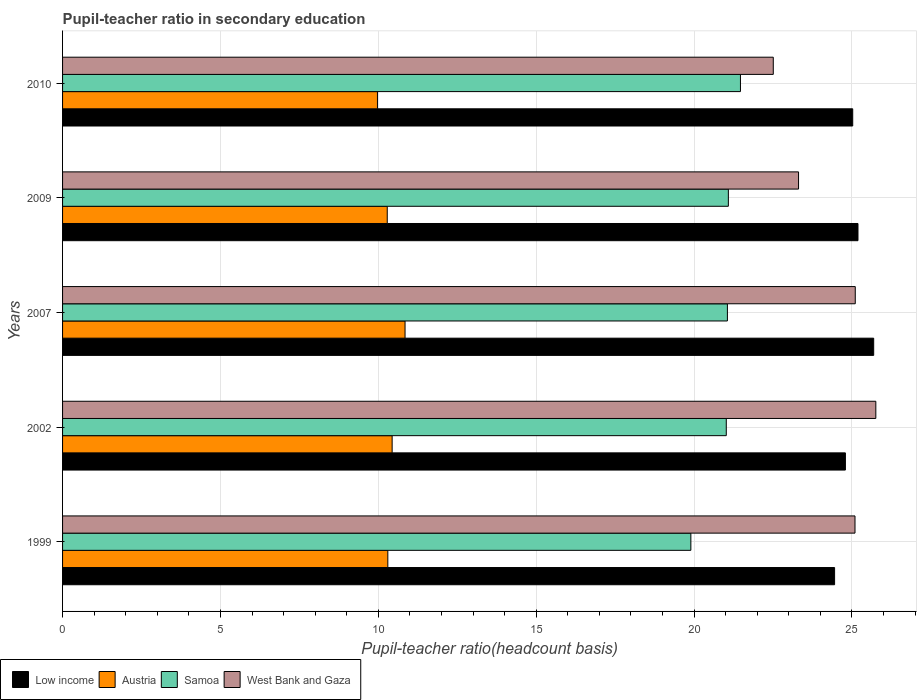How many different coloured bars are there?
Your answer should be compact. 4. How many groups of bars are there?
Ensure brevity in your answer.  5. Are the number of bars on each tick of the Y-axis equal?
Provide a short and direct response. Yes. What is the label of the 3rd group of bars from the top?
Ensure brevity in your answer.  2007. In how many cases, is the number of bars for a given year not equal to the number of legend labels?
Provide a short and direct response. 0. What is the pupil-teacher ratio in secondary education in Samoa in 2009?
Offer a very short reply. 21.09. Across all years, what is the maximum pupil-teacher ratio in secondary education in Austria?
Ensure brevity in your answer.  10.85. Across all years, what is the minimum pupil-teacher ratio in secondary education in Samoa?
Your answer should be very brief. 19.9. What is the total pupil-teacher ratio in secondary education in Samoa in the graph?
Offer a very short reply. 104.53. What is the difference between the pupil-teacher ratio in secondary education in Low income in 1999 and that in 2010?
Your answer should be very brief. -0.57. What is the difference between the pupil-teacher ratio in secondary education in West Bank and Gaza in 2009 and the pupil-teacher ratio in secondary education in Low income in 2002?
Make the answer very short. -1.48. What is the average pupil-teacher ratio in secondary education in Samoa per year?
Provide a short and direct response. 20.91. In the year 2002, what is the difference between the pupil-teacher ratio in secondary education in Samoa and pupil-teacher ratio in secondary education in Austria?
Make the answer very short. 10.58. In how many years, is the pupil-teacher ratio in secondary education in West Bank and Gaza greater than 5 ?
Give a very brief answer. 5. What is the ratio of the pupil-teacher ratio in secondary education in Samoa in 2002 to that in 2007?
Provide a short and direct response. 1. Is the difference between the pupil-teacher ratio in secondary education in Samoa in 1999 and 2002 greater than the difference between the pupil-teacher ratio in secondary education in Austria in 1999 and 2002?
Give a very brief answer. No. What is the difference between the highest and the second highest pupil-teacher ratio in secondary education in Austria?
Provide a succinct answer. 0.41. What is the difference between the highest and the lowest pupil-teacher ratio in secondary education in Austria?
Offer a very short reply. 0.87. Is the sum of the pupil-teacher ratio in secondary education in Austria in 2002 and 2009 greater than the maximum pupil-teacher ratio in secondary education in Samoa across all years?
Provide a succinct answer. No. Is it the case that in every year, the sum of the pupil-teacher ratio in secondary education in Austria and pupil-teacher ratio in secondary education in Low income is greater than the sum of pupil-teacher ratio in secondary education in West Bank and Gaza and pupil-teacher ratio in secondary education in Samoa?
Give a very brief answer. Yes. What does the 3rd bar from the top in 2007 represents?
Your response must be concise. Austria. What does the 1st bar from the bottom in 2010 represents?
Make the answer very short. Low income. How many bars are there?
Provide a short and direct response. 20. Are all the bars in the graph horizontal?
Give a very brief answer. Yes. How many years are there in the graph?
Ensure brevity in your answer.  5. What is the difference between two consecutive major ticks on the X-axis?
Provide a short and direct response. 5. Are the values on the major ticks of X-axis written in scientific E-notation?
Keep it short and to the point. No. Does the graph contain grids?
Give a very brief answer. Yes. Where does the legend appear in the graph?
Keep it short and to the point. Bottom left. How many legend labels are there?
Offer a terse response. 4. What is the title of the graph?
Your answer should be compact. Pupil-teacher ratio in secondary education. Does "Algeria" appear as one of the legend labels in the graph?
Offer a very short reply. No. What is the label or title of the X-axis?
Ensure brevity in your answer.  Pupil-teacher ratio(headcount basis). What is the Pupil-teacher ratio(headcount basis) in Low income in 1999?
Offer a very short reply. 24.45. What is the Pupil-teacher ratio(headcount basis) in Austria in 1999?
Ensure brevity in your answer.  10.3. What is the Pupil-teacher ratio(headcount basis) in Samoa in 1999?
Your answer should be compact. 19.9. What is the Pupil-teacher ratio(headcount basis) of West Bank and Gaza in 1999?
Provide a succinct answer. 25.1. What is the Pupil-teacher ratio(headcount basis) in Low income in 2002?
Your answer should be very brief. 24.79. What is the Pupil-teacher ratio(headcount basis) of Austria in 2002?
Your answer should be very brief. 10.44. What is the Pupil-teacher ratio(headcount basis) of Samoa in 2002?
Keep it short and to the point. 21.02. What is the Pupil-teacher ratio(headcount basis) in West Bank and Gaza in 2002?
Keep it short and to the point. 25.76. What is the Pupil-teacher ratio(headcount basis) in Low income in 2007?
Offer a very short reply. 25.69. What is the Pupil-teacher ratio(headcount basis) in Austria in 2007?
Your answer should be compact. 10.85. What is the Pupil-teacher ratio(headcount basis) in Samoa in 2007?
Your answer should be compact. 21.05. What is the Pupil-teacher ratio(headcount basis) of West Bank and Gaza in 2007?
Ensure brevity in your answer.  25.1. What is the Pupil-teacher ratio(headcount basis) in Low income in 2009?
Your answer should be very brief. 25.19. What is the Pupil-teacher ratio(headcount basis) of Austria in 2009?
Your answer should be compact. 10.28. What is the Pupil-teacher ratio(headcount basis) in Samoa in 2009?
Make the answer very short. 21.09. What is the Pupil-teacher ratio(headcount basis) in West Bank and Gaza in 2009?
Your response must be concise. 23.31. What is the Pupil-teacher ratio(headcount basis) of Low income in 2010?
Make the answer very short. 25.02. What is the Pupil-teacher ratio(headcount basis) of Austria in 2010?
Your answer should be very brief. 9.97. What is the Pupil-teacher ratio(headcount basis) in Samoa in 2010?
Make the answer very short. 21.47. What is the Pupil-teacher ratio(headcount basis) in West Bank and Gaza in 2010?
Ensure brevity in your answer.  22.51. Across all years, what is the maximum Pupil-teacher ratio(headcount basis) in Low income?
Keep it short and to the point. 25.69. Across all years, what is the maximum Pupil-teacher ratio(headcount basis) of Austria?
Your answer should be compact. 10.85. Across all years, what is the maximum Pupil-teacher ratio(headcount basis) in Samoa?
Your answer should be compact. 21.47. Across all years, what is the maximum Pupil-teacher ratio(headcount basis) of West Bank and Gaza?
Make the answer very short. 25.76. Across all years, what is the minimum Pupil-teacher ratio(headcount basis) of Low income?
Your answer should be compact. 24.45. Across all years, what is the minimum Pupil-teacher ratio(headcount basis) in Austria?
Provide a succinct answer. 9.97. Across all years, what is the minimum Pupil-teacher ratio(headcount basis) of Samoa?
Your answer should be compact. 19.9. Across all years, what is the minimum Pupil-teacher ratio(headcount basis) in West Bank and Gaza?
Your response must be concise. 22.51. What is the total Pupil-teacher ratio(headcount basis) in Low income in the graph?
Your response must be concise. 125.14. What is the total Pupil-teacher ratio(headcount basis) in Austria in the graph?
Provide a succinct answer. 51.84. What is the total Pupil-teacher ratio(headcount basis) in Samoa in the graph?
Keep it short and to the point. 104.53. What is the total Pupil-teacher ratio(headcount basis) in West Bank and Gaza in the graph?
Ensure brevity in your answer.  121.77. What is the difference between the Pupil-teacher ratio(headcount basis) of Low income in 1999 and that in 2002?
Your answer should be very brief. -0.34. What is the difference between the Pupil-teacher ratio(headcount basis) in Austria in 1999 and that in 2002?
Offer a very short reply. -0.14. What is the difference between the Pupil-teacher ratio(headcount basis) in Samoa in 1999 and that in 2002?
Make the answer very short. -1.12. What is the difference between the Pupil-teacher ratio(headcount basis) of West Bank and Gaza in 1999 and that in 2002?
Give a very brief answer. -0.66. What is the difference between the Pupil-teacher ratio(headcount basis) in Low income in 1999 and that in 2007?
Offer a very short reply. -1.24. What is the difference between the Pupil-teacher ratio(headcount basis) in Austria in 1999 and that in 2007?
Provide a succinct answer. -0.55. What is the difference between the Pupil-teacher ratio(headcount basis) in Samoa in 1999 and that in 2007?
Ensure brevity in your answer.  -1.16. What is the difference between the Pupil-teacher ratio(headcount basis) in West Bank and Gaza in 1999 and that in 2007?
Your answer should be very brief. -0.01. What is the difference between the Pupil-teacher ratio(headcount basis) of Low income in 1999 and that in 2009?
Give a very brief answer. -0.74. What is the difference between the Pupil-teacher ratio(headcount basis) in Austria in 1999 and that in 2009?
Your answer should be compact. 0.02. What is the difference between the Pupil-teacher ratio(headcount basis) of Samoa in 1999 and that in 2009?
Keep it short and to the point. -1.19. What is the difference between the Pupil-teacher ratio(headcount basis) of West Bank and Gaza in 1999 and that in 2009?
Provide a succinct answer. 1.79. What is the difference between the Pupil-teacher ratio(headcount basis) of Low income in 1999 and that in 2010?
Your answer should be compact. -0.57. What is the difference between the Pupil-teacher ratio(headcount basis) in Austria in 1999 and that in 2010?
Your answer should be compact. 0.33. What is the difference between the Pupil-teacher ratio(headcount basis) of Samoa in 1999 and that in 2010?
Give a very brief answer. -1.57. What is the difference between the Pupil-teacher ratio(headcount basis) of West Bank and Gaza in 1999 and that in 2010?
Keep it short and to the point. 2.59. What is the difference between the Pupil-teacher ratio(headcount basis) of Low income in 2002 and that in 2007?
Provide a short and direct response. -0.9. What is the difference between the Pupil-teacher ratio(headcount basis) in Austria in 2002 and that in 2007?
Make the answer very short. -0.41. What is the difference between the Pupil-teacher ratio(headcount basis) in Samoa in 2002 and that in 2007?
Offer a very short reply. -0.04. What is the difference between the Pupil-teacher ratio(headcount basis) of West Bank and Gaza in 2002 and that in 2007?
Your answer should be compact. 0.65. What is the difference between the Pupil-teacher ratio(headcount basis) of Low income in 2002 and that in 2009?
Your answer should be very brief. -0.4. What is the difference between the Pupil-teacher ratio(headcount basis) of Austria in 2002 and that in 2009?
Ensure brevity in your answer.  0.15. What is the difference between the Pupil-teacher ratio(headcount basis) in Samoa in 2002 and that in 2009?
Your answer should be compact. -0.07. What is the difference between the Pupil-teacher ratio(headcount basis) of West Bank and Gaza in 2002 and that in 2009?
Keep it short and to the point. 2.45. What is the difference between the Pupil-teacher ratio(headcount basis) of Low income in 2002 and that in 2010?
Keep it short and to the point. -0.23. What is the difference between the Pupil-teacher ratio(headcount basis) of Austria in 2002 and that in 2010?
Make the answer very short. 0.46. What is the difference between the Pupil-teacher ratio(headcount basis) in Samoa in 2002 and that in 2010?
Provide a short and direct response. -0.45. What is the difference between the Pupil-teacher ratio(headcount basis) in West Bank and Gaza in 2002 and that in 2010?
Keep it short and to the point. 3.25. What is the difference between the Pupil-teacher ratio(headcount basis) in Low income in 2007 and that in 2009?
Offer a very short reply. 0.5. What is the difference between the Pupil-teacher ratio(headcount basis) of Austria in 2007 and that in 2009?
Your answer should be very brief. 0.56. What is the difference between the Pupil-teacher ratio(headcount basis) in Samoa in 2007 and that in 2009?
Your answer should be compact. -0.03. What is the difference between the Pupil-teacher ratio(headcount basis) of West Bank and Gaza in 2007 and that in 2009?
Make the answer very short. 1.8. What is the difference between the Pupil-teacher ratio(headcount basis) of Low income in 2007 and that in 2010?
Provide a succinct answer. 0.66. What is the difference between the Pupil-teacher ratio(headcount basis) of Austria in 2007 and that in 2010?
Give a very brief answer. 0.87. What is the difference between the Pupil-teacher ratio(headcount basis) of Samoa in 2007 and that in 2010?
Your answer should be compact. -0.41. What is the difference between the Pupil-teacher ratio(headcount basis) of West Bank and Gaza in 2007 and that in 2010?
Keep it short and to the point. 2.6. What is the difference between the Pupil-teacher ratio(headcount basis) of Low income in 2009 and that in 2010?
Your answer should be compact. 0.17. What is the difference between the Pupil-teacher ratio(headcount basis) of Austria in 2009 and that in 2010?
Offer a terse response. 0.31. What is the difference between the Pupil-teacher ratio(headcount basis) in Samoa in 2009 and that in 2010?
Offer a terse response. -0.38. What is the difference between the Pupil-teacher ratio(headcount basis) of West Bank and Gaza in 2009 and that in 2010?
Your answer should be very brief. 0.8. What is the difference between the Pupil-teacher ratio(headcount basis) of Low income in 1999 and the Pupil-teacher ratio(headcount basis) of Austria in 2002?
Your answer should be compact. 14.01. What is the difference between the Pupil-teacher ratio(headcount basis) of Low income in 1999 and the Pupil-teacher ratio(headcount basis) of Samoa in 2002?
Ensure brevity in your answer.  3.43. What is the difference between the Pupil-teacher ratio(headcount basis) of Low income in 1999 and the Pupil-teacher ratio(headcount basis) of West Bank and Gaza in 2002?
Provide a short and direct response. -1.31. What is the difference between the Pupil-teacher ratio(headcount basis) in Austria in 1999 and the Pupil-teacher ratio(headcount basis) in Samoa in 2002?
Make the answer very short. -10.72. What is the difference between the Pupil-teacher ratio(headcount basis) in Austria in 1999 and the Pupil-teacher ratio(headcount basis) in West Bank and Gaza in 2002?
Offer a terse response. -15.45. What is the difference between the Pupil-teacher ratio(headcount basis) in Samoa in 1999 and the Pupil-teacher ratio(headcount basis) in West Bank and Gaza in 2002?
Ensure brevity in your answer.  -5.86. What is the difference between the Pupil-teacher ratio(headcount basis) of Low income in 1999 and the Pupil-teacher ratio(headcount basis) of Austria in 2007?
Give a very brief answer. 13.6. What is the difference between the Pupil-teacher ratio(headcount basis) of Low income in 1999 and the Pupil-teacher ratio(headcount basis) of Samoa in 2007?
Ensure brevity in your answer.  3.39. What is the difference between the Pupil-teacher ratio(headcount basis) in Low income in 1999 and the Pupil-teacher ratio(headcount basis) in West Bank and Gaza in 2007?
Give a very brief answer. -0.65. What is the difference between the Pupil-teacher ratio(headcount basis) in Austria in 1999 and the Pupil-teacher ratio(headcount basis) in Samoa in 2007?
Offer a very short reply. -10.75. What is the difference between the Pupil-teacher ratio(headcount basis) of Austria in 1999 and the Pupil-teacher ratio(headcount basis) of West Bank and Gaza in 2007?
Keep it short and to the point. -14.8. What is the difference between the Pupil-teacher ratio(headcount basis) in Samoa in 1999 and the Pupil-teacher ratio(headcount basis) in West Bank and Gaza in 2007?
Give a very brief answer. -5.21. What is the difference between the Pupil-teacher ratio(headcount basis) in Low income in 1999 and the Pupil-teacher ratio(headcount basis) in Austria in 2009?
Ensure brevity in your answer.  14.17. What is the difference between the Pupil-teacher ratio(headcount basis) in Low income in 1999 and the Pupil-teacher ratio(headcount basis) in Samoa in 2009?
Make the answer very short. 3.36. What is the difference between the Pupil-teacher ratio(headcount basis) of Low income in 1999 and the Pupil-teacher ratio(headcount basis) of West Bank and Gaza in 2009?
Provide a succinct answer. 1.14. What is the difference between the Pupil-teacher ratio(headcount basis) in Austria in 1999 and the Pupil-teacher ratio(headcount basis) in Samoa in 2009?
Give a very brief answer. -10.78. What is the difference between the Pupil-teacher ratio(headcount basis) in Austria in 1999 and the Pupil-teacher ratio(headcount basis) in West Bank and Gaza in 2009?
Keep it short and to the point. -13.01. What is the difference between the Pupil-teacher ratio(headcount basis) in Samoa in 1999 and the Pupil-teacher ratio(headcount basis) in West Bank and Gaza in 2009?
Ensure brevity in your answer.  -3.41. What is the difference between the Pupil-teacher ratio(headcount basis) of Low income in 1999 and the Pupil-teacher ratio(headcount basis) of Austria in 2010?
Your answer should be very brief. 14.48. What is the difference between the Pupil-teacher ratio(headcount basis) in Low income in 1999 and the Pupil-teacher ratio(headcount basis) in Samoa in 2010?
Provide a short and direct response. 2.98. What is the difference between the Pupil-teacher ratio(headcount basis) in Low income in 1999 and the Pupil-teacher ratio(headcount basis) in West Bank and Gaza in 2010?
Your response must be concise. 1.94. What is the difference between the Pupil-teacher ratio(headcount basis) of Austria in 1999 and the Pupil-teacher ratio(headcount basis) of Samoa in 2010?
Your answer should be very brief. -11.17. What is the difference between the Pupil-teacher ratio(headcount basis) in Austria in 1999 and the Pupil-teacher ratio(headcount basis) in West Bank and Gaza in 2010?
Keep it short and to the point. -12.21. What is the difference between the Pupil-teacher ratio(headcount basis) of Samoa in 1999 and the Pupil-teacher ratio(headcount basis) of West Bank and Gaza in 2010?
Give a very brief answer. -2.61. What is the difference between the Pupil-teacher ratio(headcount basis) of Low income in 2002 and the Pupil-teacher ratio(headcount basis) of Austria in 2007?
Your answer should be very brief. 13.95. What is the difference between the Pupil-teacher ratio(headcount basis) of Low income in 2002 and the Pupil-teacher ratio(headcount basis) of Samoa in 2007?
Provide a succinct answer. 3.74. What is the difference between the Pupil-teacher ratio(headcount basis) of Low income in 2002 and the Pupil-teacher ratio(headcount basis) of West Bank and Gaza in 2007?
Ensure brevity in your answer.  -0.31. What is the difference between the Pupil-teacher ratio(headcount basis) in Austria in 2002 and the Pupil-teacher ratio(headcount basis) in Samoa in 2007?
Your answer should be very brief. -10.62. What is the difference between the Pupil-teacher ratio(headcount basis) of Austria in 2002 and the Pupil-teacher ratio(headcount basis) of West Bank and Gaza in 2007?
Offer a very short reply. -14.67. What is the difference between the Pupil-teacher ratio(headcount basis) of Samoa in 2002 and the Pupil-teacher ratio(headcount basis) of West Bank and Gaza in 2007?
Your response must be concise. -4.08. What is the difference between the Pupil-teacher ratio(headcount basis) in Low income in 2002 and the Pupil-teacher ratio(headcount basis) in Austria in 2009?
Provide a succinct answer. 14.51. What is the difference between the Pupil-teacher ratio(headcount basis) in Low income in 2002 and the Pupil-teacher ratio(headcount basis) in Samoa in 2009?
Provide a succinct answer. 3.71. What is the difference between the Pupil-teacher ratio(headcount basis) in Low income in 2002 and the Pupil-teacher ratio(headcount basis) in West Bank and Gaza in 2009?
Offer a very short reply. 1.48. What is the difference between the Pupil-teacher ratio(headcount basis) in Austria in 2002 and the Pupil-teacher ratio(headcount basis) in Samoa in 2009?
Your response must be concise. -10.65. What is the difference between the Pupil-teacher ratio(headcount basis) in Austria in 2002 and the Pupil-teacher ratio(headcount basis) in West Bank and Gaza in 2009?
Provide a short and direct response. -12.87. What is the difference between the Pupil-teacher ratio(headcount basis) in Samoa in 2002 and the Pupil-teacher ratio(headcount basis) in West Bank and Gaza in 2009?
Your answer should be very brief. -2.29. What is the difference between the Pupil-teacher ratio(headcount basis) of Low income in 2002 and the Pupil-teacher ratio(headcount basis) of Austria in 2010?
Offer a terse response. 14.82. What is the difference between the Pupil-teacher ratio(headcount basis) of Low income in 2002 and the Pupil-teacher ratio(headcount basis) of Samoa in 2010?
Your answer should be compact. 3.32. What is the difference between the Pupil-teacher ratio(headcount basis) of Low income in 2002 and the Pupil-teacher ratio(headcount basis) of West Bank and Gaza in 2010?
Ensure brevity in your answer.  2.28. What is the difference between the Pupil-teacher ratio(headcount basis) of Austria in 2002 and the Pupil-teacher ratio(headcount basis) of Samoa in 2010?
Make the answer very short. -11.03. What is the difference between the Pupil-teacher ratio(headcount basis) of Austria in 2002 and the Pupil-teacher ratio(headcount basis) of West Bank and Gaza in 2010?
Ensure brevity in your answer.  -12.07. What is the difference between the Pupil-teacher ratio(headcount basis) of Samoa in 2002 and the Pupil-teacher ratio(headcount basis) of West Bank and Gaza in 2010?
Your response must be concise. -1.49. What is the difference between the Pupil-teacher ratio(headcount basis) of Low income in 2007 and the Pupil-teacher ratio(headcount basis) of Austria in 2009?
Your answer should be compact. 15.41. What is the difference between the Pupil-teacher ratio(headcount basis) in Low income in 2007 and the Pupil-teacher ratio(headcount basis) in Samoa in 2009?
Your answer should be compact. 4.6. What is the difference between the Pupil-teacher ratio(headcount basis) of Low income in 2007 and the Pupil-teacher ratio(headcount basis) of West Bank and Gaza in 2009?
Give a very brief answer. 2.38. What is the difference between the Pupil-teacher ratio(headcount basis) of Austria in 2007 and the Pupil-teacher ratio(headcount basis) of Samoa in 2009?
Make the answer very short. -10.24. What is the difference between the Pupil-teacher ratio(headcount basis) in Austria in 2007 and the Pupil-teacher ratio(headcount basis) in West Bank and Gaza in 2009?
Offer a very short reply. -12.46. What is the difference between the Pupil-teacher ratio(headcount basis) in Samoa in 2007 and the Pupil-teacher ratio(headcount basis) in West Bank and Gaza in 2009?
Ensure brevity in your answer.  -2.25. What is the difference between the Pupil-teacher ratio(headcount basis) in Low income in 2007 and the Pupil-teacher ratio(headcount basis) in Austria in 2010?
Provide a succinct answer. 15.72. What is the difference between the Pupil-teacher ratio(headcount basis) in Low income in 2007 and the Pupil-teacher ratio(headcount basis) in Samoa in 2010?
Your response must be concise. 4.22. What is the difference between the Pupil-teacher ratio(headcount basis) in Low income in 2007 and the Pupil-teacher ratio(headcount basis) in West Bank and Gaza in 2010?
Your answer should be very brief. 3.18. What is the difference between the Pupil-teacher ratio(headcount basis) of Austria in 2007 and the Pupil-teacher ratio(headcount basis) of Samoa in 2010?
Make the answer very short. -10.62. What is the difference between the Pupil-teacher ratio(headcount basis) in Austria in 2007 and the Pupil-teacher ratio(headcount basis) in West Bank and Gaza in 2010?
Give a very brief answer. -11.66. What is the difference between the Pupil-teacher ratio(headcount basis) of Samoa in 2007 and the Pupil-teacher ratio(headcount basis) of West Bank and Gaza in 2010?
Ensure brevity in your answer.  -1.45. What is the difference between the Pupil-teacher ratio(headcount basis) in Low income in 2009 and the Pupil-teacher ratio(headcount basis) in Austria in 2010?
Provide a succinct answer. 15.22. What is the difference between the Pupil-teacher ratio(headcount basis) in Low income in 2009 and the Pupil-teacher ratio(headcount basis) in Samoa in 2010?
Your answer should be very brief. 3.72. What is the difference between the Pupil-teacher ratio(headcount basis) of Low income in 2009 and the Pupil-teacher ratio(headcount basis) of West Bank and Gaza in 2010?
Provide a short and direct response. 2.68. What is the difference between the Pupil-teacher ratio(headcount basis) of Austria in 2009 and the Pupil-teacher ratio(headcount basis) of Samoa in 2010?
Give a very brief answer. -11.19. What is the difference between the Pupil-teacher ratio(headcount basis) in Austria in 2009 and the Pupil-teacher ratio(headcount basis) in West Bank and Gaza in 2010?
Your response must be concise. -12.23. What is the difference between the Pupil-teacher ratio(headcount basis) in Samoa in 2009 and the Pupil-teacher ratio(headcount basis) in West Bank and Gaza in 2010?
Give a very brief answer. -1.42. What is the average Pupil-teacher ratio(headcount basis) of Low income per year?
Ensure brevity in your answer.  25.03. What is the average Pupil-teacher ratio(headcount basis) of Austria per year?
Provide a succinct answer. 10.37. What is the average Pupil-teacher ratio(headcount basis) of Samoa per year?
Your response must be concise. 20.91. What is the average Pupil-teacher ratio(headcount basis) of West Bank and Gaza per year?
Your answer should be very brief. 24.35. In the year 1999, what is the difference between the Pupil-teacher ratio(headcount basis) of Low income and Pupil-teacher ratio(headcount basis) of Austria?
Your answer should be very brief. 14.15. In the year 1999, what is the difference between the Pupil-teacher ratio(headcount basis) of Low income and Pupil-teacher ratio(headcount basis) of Samoa?
Your answer should be very brief. 4.55. In the year 1999, what is the difference between the Pupil-teacher ratio(headcount basis) in Low income and Pupil-teacher ratio(headcount basis) in West Bank and Gaza?
Make the answer very short. -0.65. In the year 1999, what is the difference between the Pupil-teacher ratio(headcount basis) in Austria and Pupil-teacher ratio(headcount basis) in Samoa?
Your response must be concise. -9.6. In the year 1999, what is the difference between the Pupil-teacher ratio(headcount basis) of Austria and Pupil-teacher ratio(headcount basis) of West Bank and Gaza?
Offer a terse response. -14.8. In the year 1999, what is the difference between the Pupil-teacher ratio(headcount basis) in Samoa and Pupil-teacher ratio(headcount basis) in West Bank and Gaza?
Your response must be concise. -5.2. In the year 2002, what is the difference between the Pupil-teacher ratio(headcount basis) in Low income and Pupil-teacher ratio(headcount basis) in Austria?
Give a very brief answer. 14.35. In the year 2002, what is the difference between the Pupil-teacher ratio(headcount basis) in Low income and Pupil-teacher ratio(headcount basis) in Samoa?
Your answer should be compact. 3.77. In the year 2002, what is the difference between the Pupil-teacher ratio(headcount basis) of Low income and Pupil-teacher ratio(headcount basis) of West Bank and Gaza?
Provide a succinct answer. -0.96. In the year 2002, what is the difference between the Pupil-teacher ratio(headcount basis) of Austria and Pupil-teacher ratio(headcount basis) of Samoa?
Provide a succinct answer. -10.58. In the year 2002, what is the difference between the Pupil-teacher ratio(headcount basis) of Austria and Pupil-teacher ratio(headcount basis) of West Bank and Gaza?
Your answer should be very brief. -15.32. In the year 2002, what is the difference between the Pupil-teacher ratio(headcount basis) in Samoa and Pupil-teacher ratio(headcount basis) in West Bank and Gaza?
Give a very brief answer. -4.74. In the year 2007, what is the difference between the Pupil-teacher ratio(headcount basis) in Low income and Pupil-teacher ratio(headcount basis) in Austria?
Your response must be concise. 14.84. In the year 2007, what is the difference between the Pupil-teacher ratio(headcount basis) in Low income and Pupil-teacher ratio(headcount basis) in Samoa?
Provide a succinct answer. 4.63. In the year 2007, what is the difference between the Pupil-teacher ratio(headcount basis) of Low income and Pupil-teacher ratio(headcount basis) of West Bank and Gaza?
Offer a terse response. 0.58. In the year 2007, what is the difference between the Pupil-teacher ratio(headcount basis) in Austria and Pupil-teacher ratio(headcount basis) in Samoa?
Offer a very short reply. -10.21. In the year 2007, what is the difference between the Pupil-teacher ratio(headcount basis) in Austria and Pupil-teacher ratio(headcount basis) in West Bank and Gaza?
Provide a short and direct response. -14.26. In the year 2007, what is the difference between the Pupil-teacher ratio(headcount basis) of Samoa and Pupil-teacher ratio(headcount basis) of West Bank and Gaza?
Ensure brevity in your answer.  -4.05. In the year 2009, what is the difference between the Pupil-teacher ratio(headcount basis) in Low income and Pupil-teacher ratio(headcount basis) in Austria?
Offer a terse response. 14.91. In the year 2009, what is the difference between the Pupil-teacher ratio(headcount basis) of Low income and Pupil-teacher ratio(headcount basis) of Samoa?
Your response must be concise. 4.11. In the year 2009, what is the difference between the Pupil-teacher ratio(headcount basis) of Low income and Pupil-teacher ratio(headcount basis) of West Bank and Gaza?
Your answer should be very brief. 1.88. In the year 2009, what is the difference between the Pupil-teacher ratio(headcount basis) of Austria and Pupil-teacher ratio(headcount basis) of Samoa?
Offer a very short reply. -10.8. In the year 2009, what is the difference between the Pupil-teacher ratio(headcount basis) of Austria and Pupil-teacher ratio(headcount basis) of West Bank and Gaza?
Provide a short and direct response. -13.03. In the year 2009, what is the difference between the Pupil-teacher ratio(headcount basis) in Samoa and Pupil-teacher ratio(headcount basis) in West Bank and Gaza?
Make the answer very short. -2.22. In the year 2010, what is the difference between the Pupil-teacher ratio(headcount basis) in Low income and Pupil-teacher ratio(headcount basis) in Austria?
Your response must be concise. 15.05. In the year 2010, what is the difference between the Pupil-teacher ratio(headcount basis) in Low income and Pupil-teacher ratio(headcount basis) in Samoa?
Your response must be concise. 3.56. In the year 2010, what is the difference between the Pupil-teacher ratio(headcount basis) of Low income and Pupil-teacher ratio(headcount basis) of West Bank and Gaza?
Give a very brief answer. 2.52. In the year 2010, what is the difference between the Pupil-teacher ratio(headcount basis) of Austria and Pupil-teacher ratio(headcount basis) of Samoa?
Your answer should be compact. -11.5. In the year 2010, what is the difference between the Pupil-teacher ratio(headcount basis) in Austria and Pupil-teacher ratio(headcount basis) in West Bank and Gaza?
Your answer should be compact. -12.54. In the year 2010, what is the difference between the Pupil-teacher ratio(headcount basis) of Samoa and Pupil-teacher ratio(headcount basis) of West Bank and Gaza?
Provide a short and direct response. -1.04. What is the ratio of the Pupil-teacher ratio(headcount basis) of Low income in 1999 to that in 2002?
Your answer should be compact. 0.99. What is the ratio of the Pupil-teacher ratio(headcount basis) of Austria in 1999 to that in 2002?
Provide a succinct answer. 0.99. What is the ratio of the Pupil-teacher ratio(headcount basis) of Samoa in 1999 to that in 2002?
Your response must be concise. 0.95. What is the ratio of the Pupil-teacher ratio(headcount basis) of West Bank and Gaza in 1999 to that in 2002?
Your response must be concise. 0.97. What is the ratio of the Pupil-teacher ratio(headcount basis) in Low income in 1999 to that in 2007?
Your response must be concise. 0.95. What is the ratio of the Pupil-teacher ratio(headcount basis) of Austria in 1999 to that in 2007?
Your response must be concise. 0.95. What is the ratio of the Pupil-teacher ratio(headcount basis) in Samoa in 1999 to that in 2007?
Give a very brief answer. 0.94. What is the ratio of the Pupil-teacher ratio(headcount basis) in West Bank and Gaza in 1999 to that in 2007?
Give a very brief answer. 1. What is the ratio of the Pupil-teacher ratio(headcount basis) in Low income in 1999 to that in 2009?
Make the answer very short. 0.97. What is the ratio of the Pupil-teacher ratio(headcount basis) of Samoa in 1999 to that in 2009?
Your response must be concise. 0.94. What is the ratio of the Pupil-teacher ratio(headcount basis) in West Bank and Gaza in 1999 to that in 2009?
Provide a succinct answer. 1.08. What is the ratio of the Pupil-teacher ratio(headcount basis) of Low income in 1999 to that in 2010?
Offer a very short reply. 0.98. What is the ratio of the Pupil-teacher ratio(headcount basis) of Austria in 1999 to that in 2010?
Give a very brief answer. 1.03. What is the ratio of the Pupil-teacher ratio(headcount basis) in Samoa in 1999 to that in 2010?
Provide a succinct answer. 0.93. What is the ratio of the Pupil-teacher ratio(headcount basis) of West Bank and Gaza in 1999 to that in 2010?
Offer a terse response. 1.11. What is the ratio of the Pupil-teacher ratio(headcount basis) of Low income in 2002 to that in 2007?
Offer a very short reply. 0.97. What is the ratio of the Pupil-teacher ratio(headcount basis) of Austria in 2002 to that in 2007?
Make the answer very short. 0.96. What is the ratio of the Pupil-teacher ratio(headcount basis) of West Bank and Gaza in 2002 to that in 2007?
Ensure brevity in your answer.  1.03. What is the ratio of the Pupil-teacher ratio(headcount basis) in Low income in 2002 to that in 2009?
Make the answer very short. 0.98. What is the ratio of the Pupil-teacher ratio(headcount basis) of Austria in 2002 to that in 2009?
Offer a very short reply. 1.02. What is the ratio of the Pupil-teacher ratio(headcount basis) in West Bank and Gaza in 2002 to that in 2009?
Keep it short and to the point. 1.1. What is the ratio of the Pupil-teacher ratio(headcount basis) of Austria in 2002 to that in 2010?
Give a very brief answer. 1.05. What is the ratio of the Pupil-teacher ratio(headcount basis) of Samoa in 2002 to that in 2010?
Your answer should be very brief. 0.98. What is the ratio of the Pupil-teacher ratio(headcount basis) in West Bank and Gaza in 2002 to that in 2010?
Ensure brevity in your answer.  1.14. What is the ratio of the Pupil-teacher ratio(headcount basis) of Low income in 2007 to that in 2009?
Give a very brief answer. 1.02. What is the ratio of the Pupil-teacher ratio(headcount basis) in Austria in 2007 to that in 2009?
Provide a succinct answer. 1.05. What is the ratio of the Pupil-teacher ratio(headcount basis) of Samoa in 2007 to that in 2009?
Ensure brevity in your answer.  1. What is the ratio of the Pupil-teacher ratio(headcount basis) in West Bank and Gaza in 2007 to that in 2009?
Offer a very short reply. 1.08. What is the ratio of the Pupil-teacher ratio(headcount basis) in Low income in 2007 to that in 2010?
Your answer should be very brief. 1.03. What is the ratio of the Pupil-teacher ratio(headcount basis) in Austria in 2007 to that in 2010?
Keep it short and to the point. 1.09. What is the ratio of the Pupil-teacher ratio(headcount basis) of Samoa in 2007 to that in 2010?
Offer a very short reply. 0.98. What is the ratio of the Pupil-teacher ratio(headcount basis) in West Bank and Gaza in 2007 to that in 2010?
Make the answer very short. 1.12. What is the ratio of the Pupil-teacher ratio(headcount basis) in Low income in 2009 to that in 2010?
Offer a very short reply. 1.01. What is the ratio of the Pupil-teacher ratio(headcount basis) in Austria in 2009 to that in 2010?
Make the answer very short. 1.03. What is the ratio of the Pupil-teacher ratio(headcount basis) of Samoa in 2009 to that in 2010?
Give a very brief answer. 0.98. What is the ratio of the Pupil-teacher ratio(headcount basis) of West Bank and Gaza in 2009 to that in 2010?
Keep it short and to the point. 1.04. What is the difference between the highest and the second highest Pupil-teacher ratio(headcount basis) in Low income?
Provide a short and direct response. 0.5. What is the difference between the highest and the second highest Pupil-teacher ratio(headcount basis) of Austria?
Keep it short and to the point. 0.41. What is the difference between the highest and the second highest Pupil-teacher ratio(headcount basis) in Samoa?
Give a very brief answer. 0.38. What is the difference between the highest and the second highest Pupil-teacher ratio(headcount basis) of West Bank and Gaza?
Your answer should be very brief. 0.65. What is the difference between the highest and the lowest Pupil-teacher ratio(headcount basis) in Low income?
Provide a short and direct response. 1.24. What is the difference between the highest and the lowest Pupil-teacher ratio(headcount basis) of Austria?
Make the answer very short. 0.87. What is the difference between the highest and the lowest Pupil-teacher ratio(headcount basis) in Samoa?
Make the answer very short. 1.57. What is the difference between the highest and the lowest Pupil-teacher ratio(headcount basis) of West Bank and Gaza?
Offer a terse response. 3.25. 